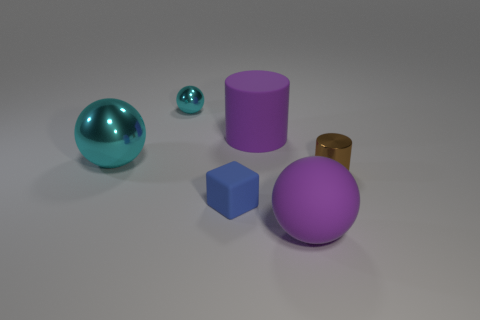Add 1 large purple rubber cylinders. How many objects exist? 7 Subtract all large purple matte spheres. How many spheres are left? 2 Subtract all cyan balls. How many balls are left? 1 Subtract all cylinders. How many objects are left? 4 Subtract 1 spheres. How many spheres are left? 2 Add 6 big gray rubber balls. How many big gray rubber balls exist? 6 Subtract 1 purple cylinders. How many objects are left? 5 Subtract all blue cylinders. Subtract all red spheres. How many cylinders are left? 2 Subtract all gray blocks. How many brown balls are left? 0 Subtract all small cyan spheres. Subtract all big shiny things. How many objects are left? 4 